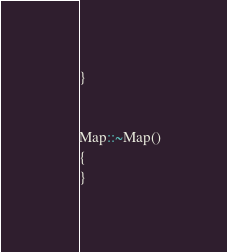<code> <loc_0><loc_0><loc_500><loc_500><_C++_>}


Map::~Map()
{
}
</code> 